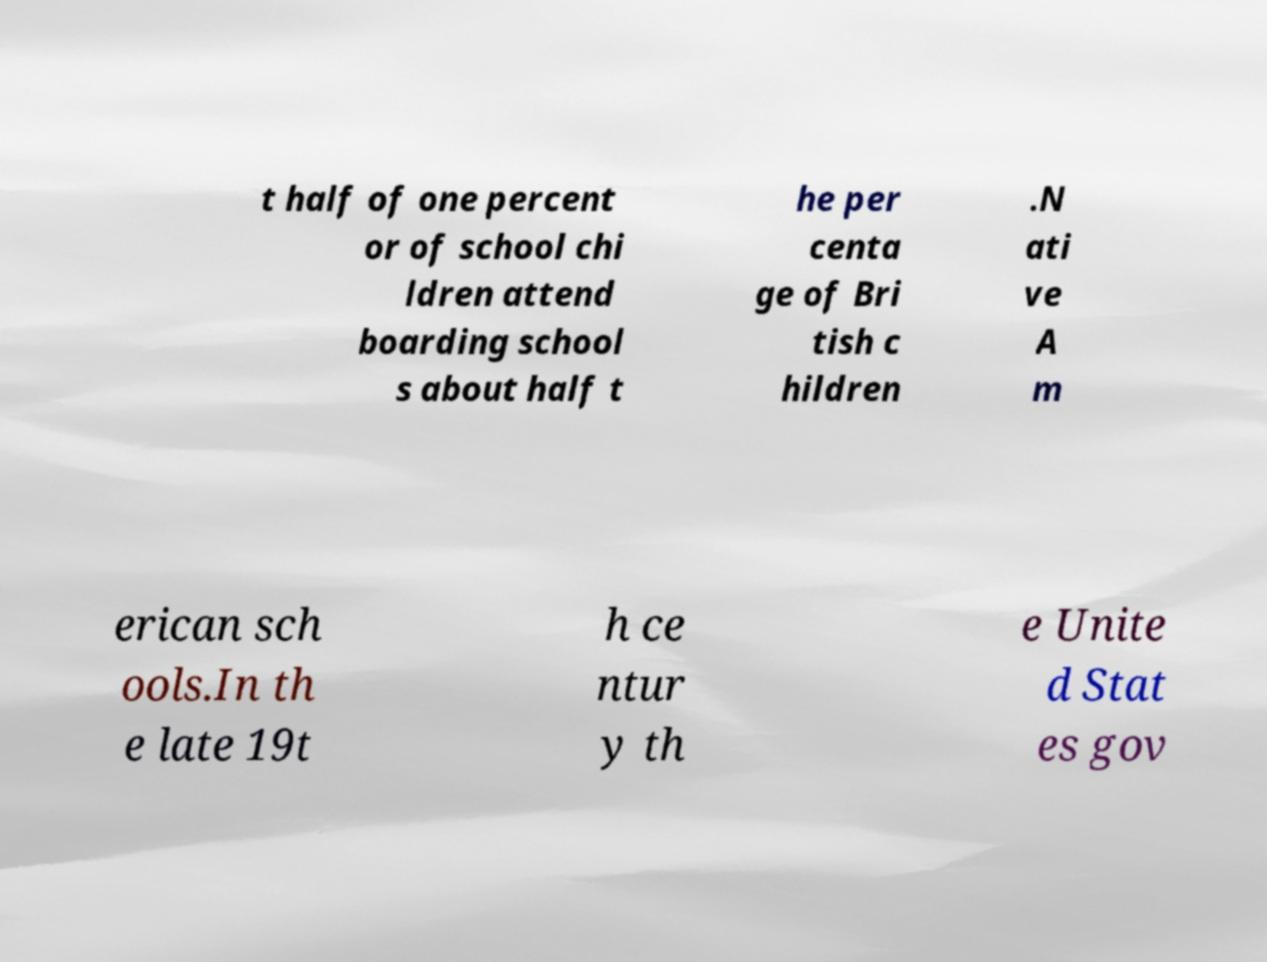I need the written content from this picture converted into text. Can you do that? t half of one percent or of school chi ldren attend boarding school s about half t he per centa ge of Bri tish c hildren .N ati ve A m erican sch ools.In th e late 19t h ce ntur y th e Unite d Stat es gov 